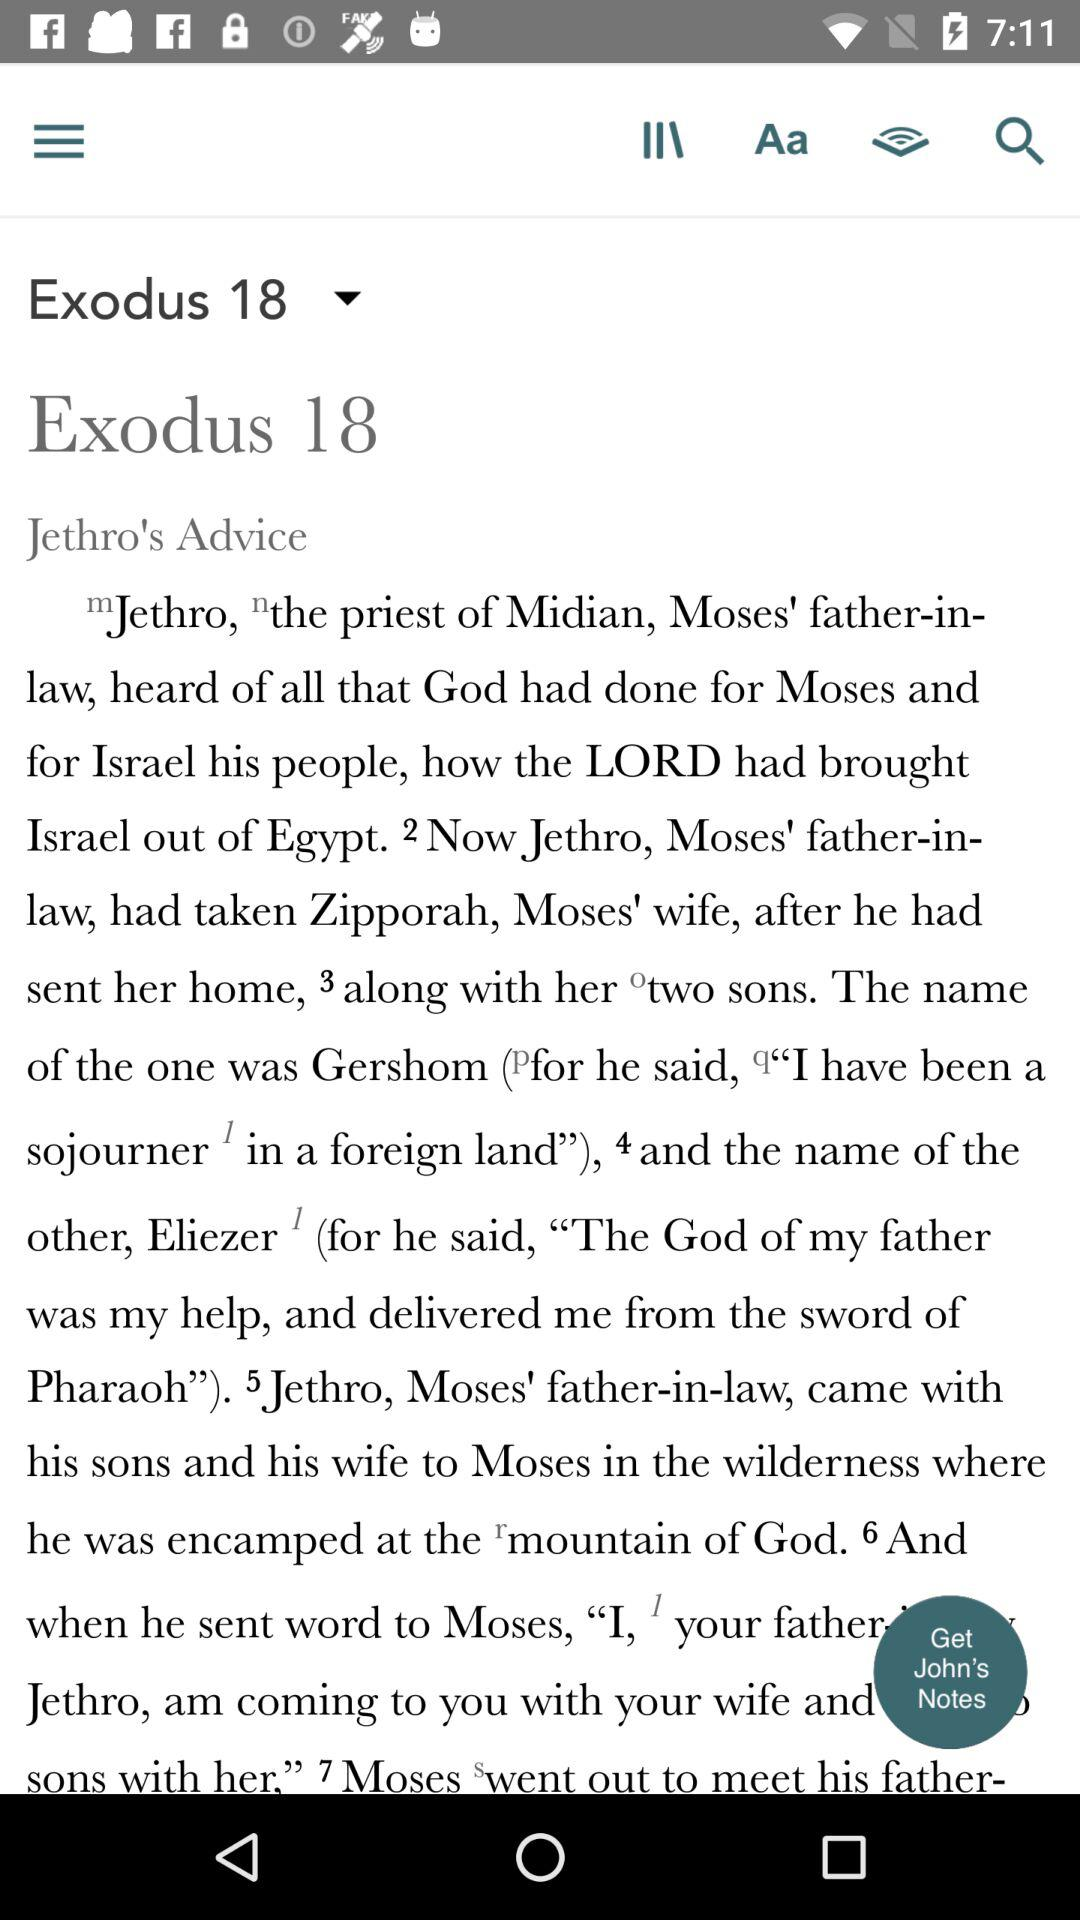What exodus is this? This is the 18th exodus. 